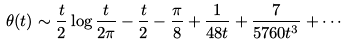Convert formula to latex. <formula><loc_0><loc_0><loc_500><loc_500>\theta ( t ) \sim { \frac { t } { 2 } } \log { \frac { t } { 2 \pi } } - { \frac { t } { 2 } } - { \frac { \pi } { 8 } } + { \frac { 1 } { 4 8 t } } + { \frac { 7 } { 5 7 6 0 t ^ { 3 } } } + \cdots</formula> 